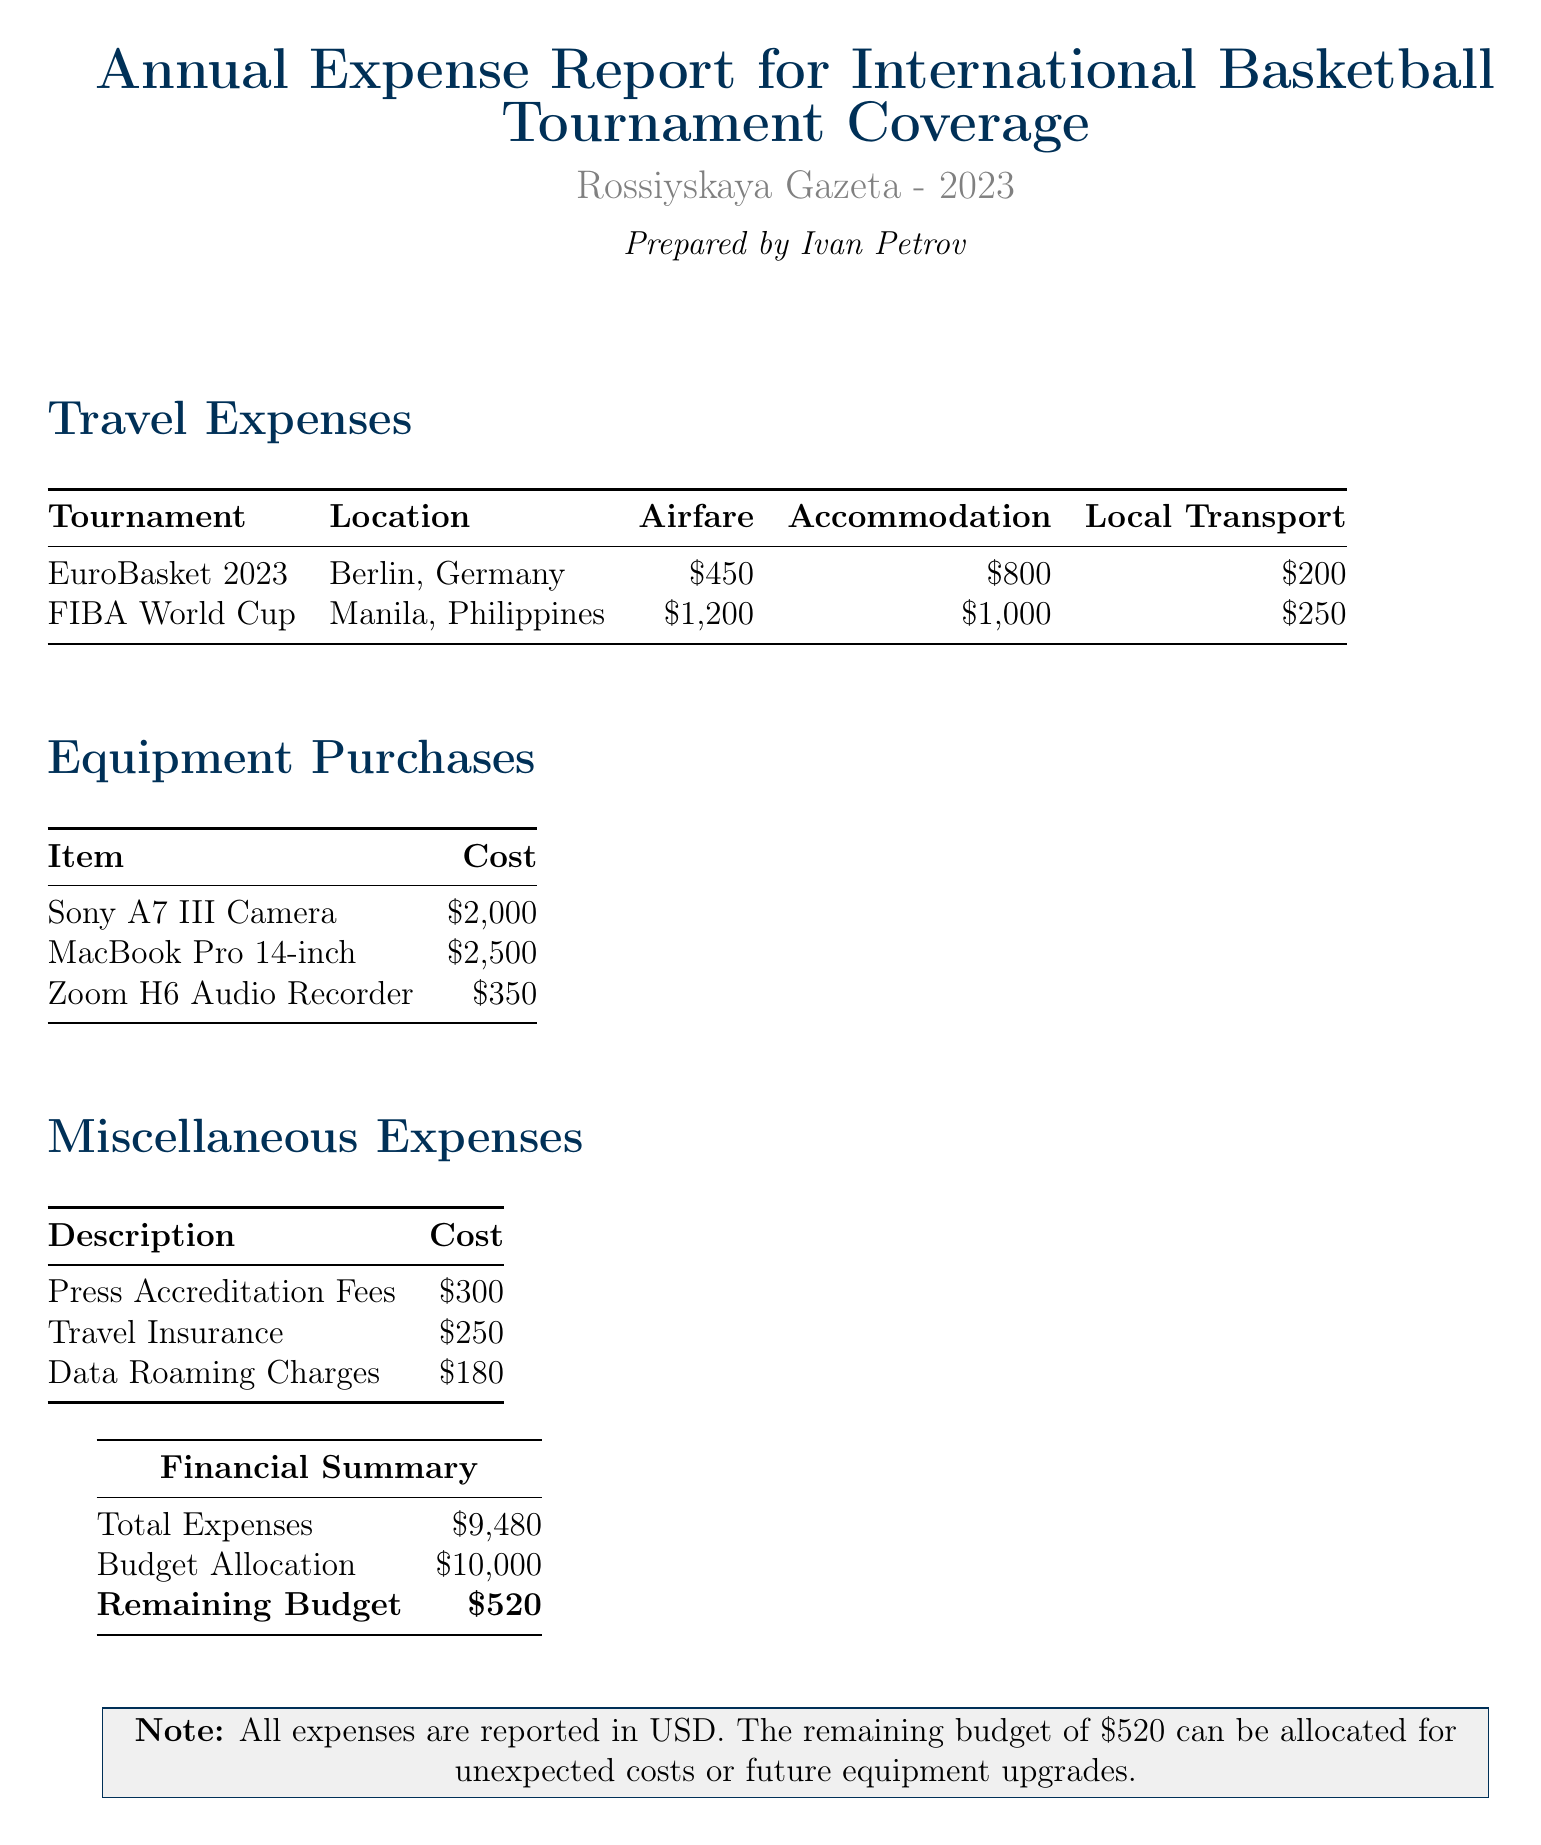What is the title of the report? The title of the report is a significant part of the document that identifies its content and purpose.
Answer: Annual Expense Report for International Basketball Tournament Coverage Who prepared the report? The name of the journalist who prepared the report provides context about the author and their association with the publication.
Answer: Ivan Petrov What is the location of the EuroBasket 2023 tournament? This information is key for understanding where the expenses were incurred for that tournament.
Answer: Berlin, Germany What was the total cost for travel to the FIBA World Cup? This cost includes airfare, accommodation, and local transportation, thus reflecting the total travel expense.
Answer: $2,450 How much was spent on equipment purchases? This total reflects the sum of all equipment costs and contributes to understanding overall expenses.
Answer: $4,850 What is the total expense amount reported? This summarizes the financial impact of the expenses incurred during the coverage of the tournaments.
Answer: $9,480 What is the remaining budget after expenses? This figure indicates the leftover funds from the budget that can be used for future needs.
Answer: $520 How much was allocated for Press Accreditation Fees? This figure illustrates specific miscellaneous costs associated with reporting from the tournaments.
Answer: $300 Which equipment item had the highest cost? Identifying the most expensive equipment item helps in understanding important investments made for coverage.
Answer: MacBook Pro 14-inch 